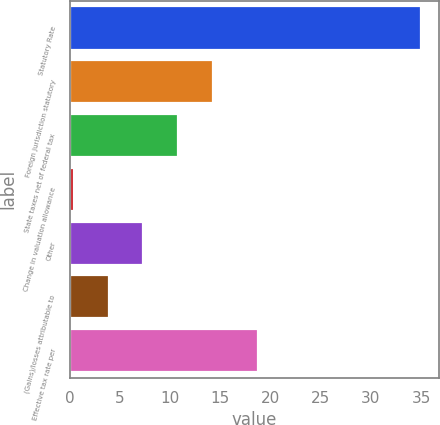Convert chart. <chart><loc_0><loc_0><loc_500><loc_500><bar_chart><fcel>Statutory Rate<fcel>Foreign jurisdiction statutory<fcel>State taxes net of federal tax<fcel>Change in valuation allowance<fcel>Other<fcel>(Gains)/losses attributable to<fcel>Effective tax rate per<nl><fcel>35<fcel>14.24<fcel>10.78<fcel>0.4<fcel>7.32<fcel>3.86<fcel>18.8<nl></chart> 